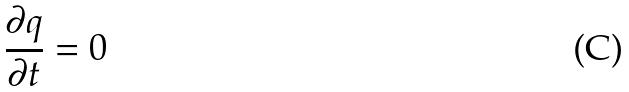<formula> <loc_0><loc_0><loc_500><loc_500>\frac { \partial q } { \partial t } = 0</formula> 